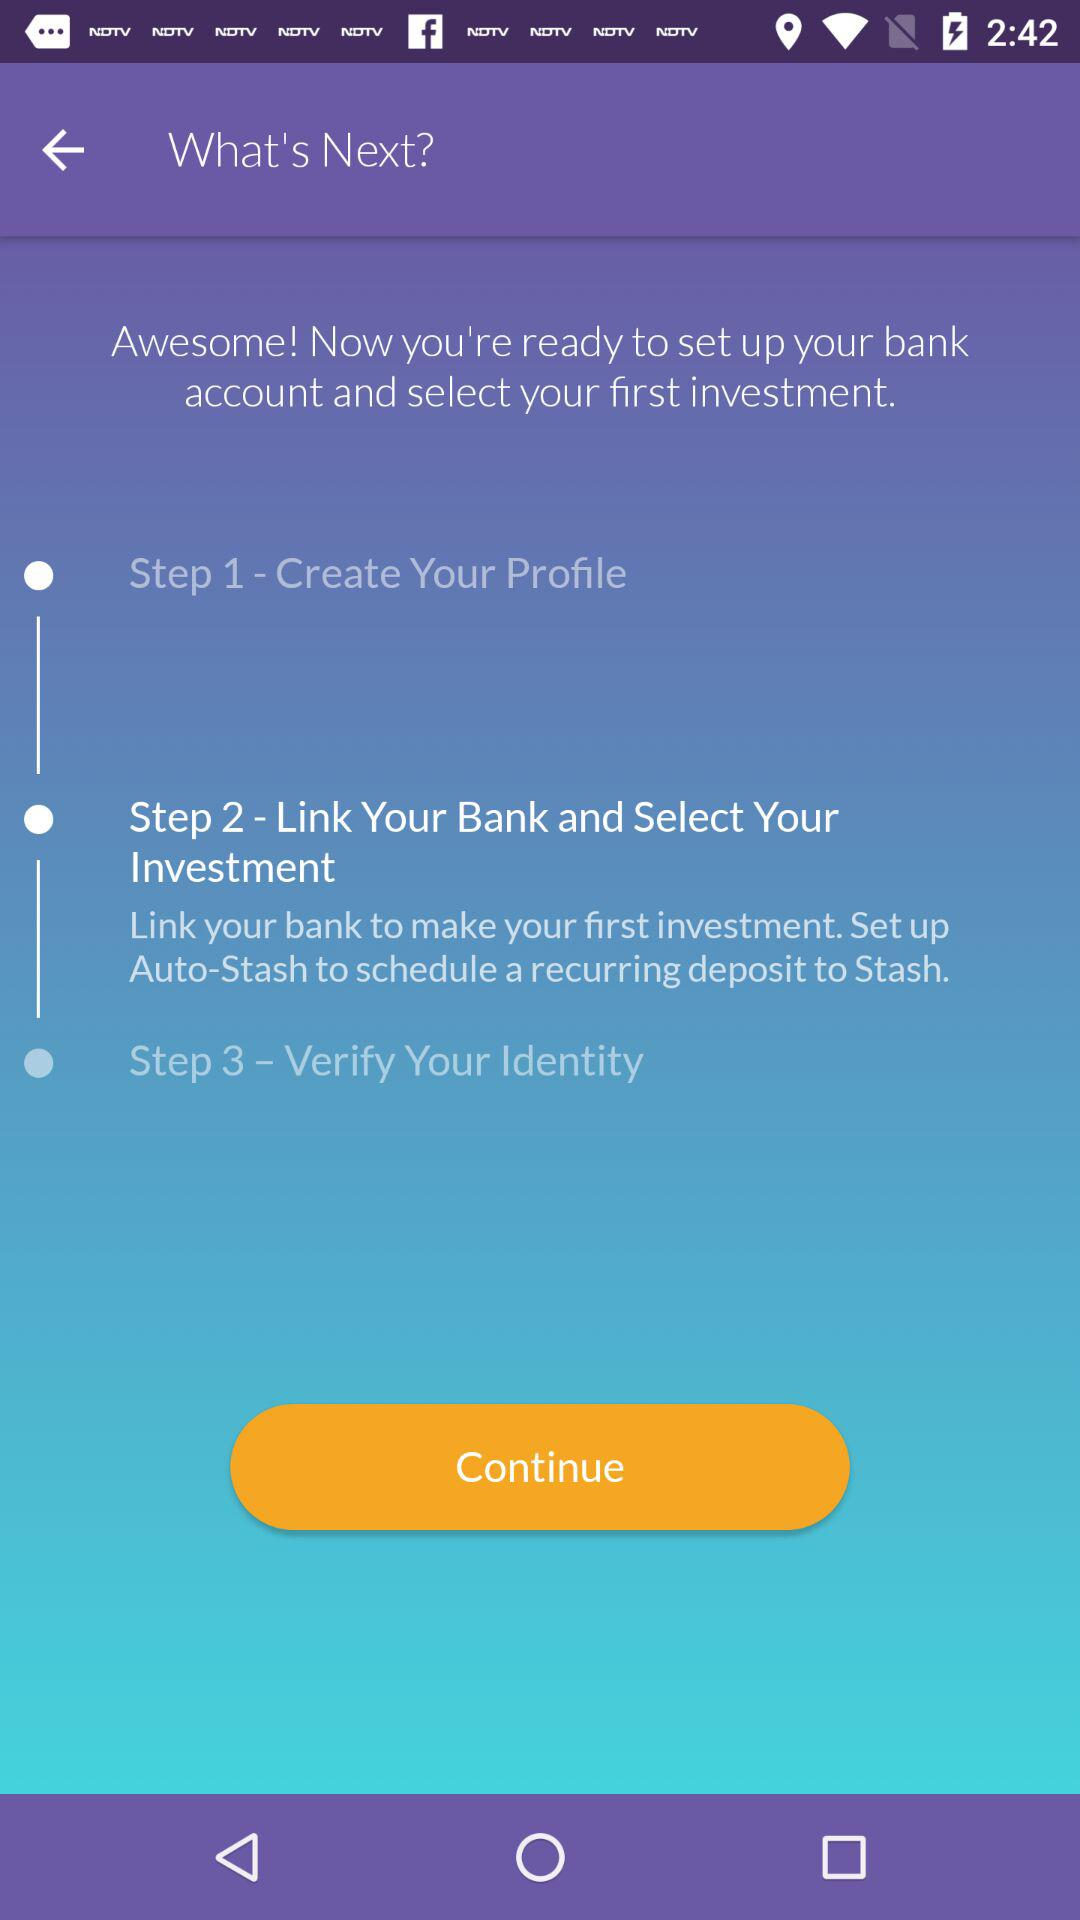How many steps are there in the onboarding process?
Answer the question using a single word or phrase. 3 